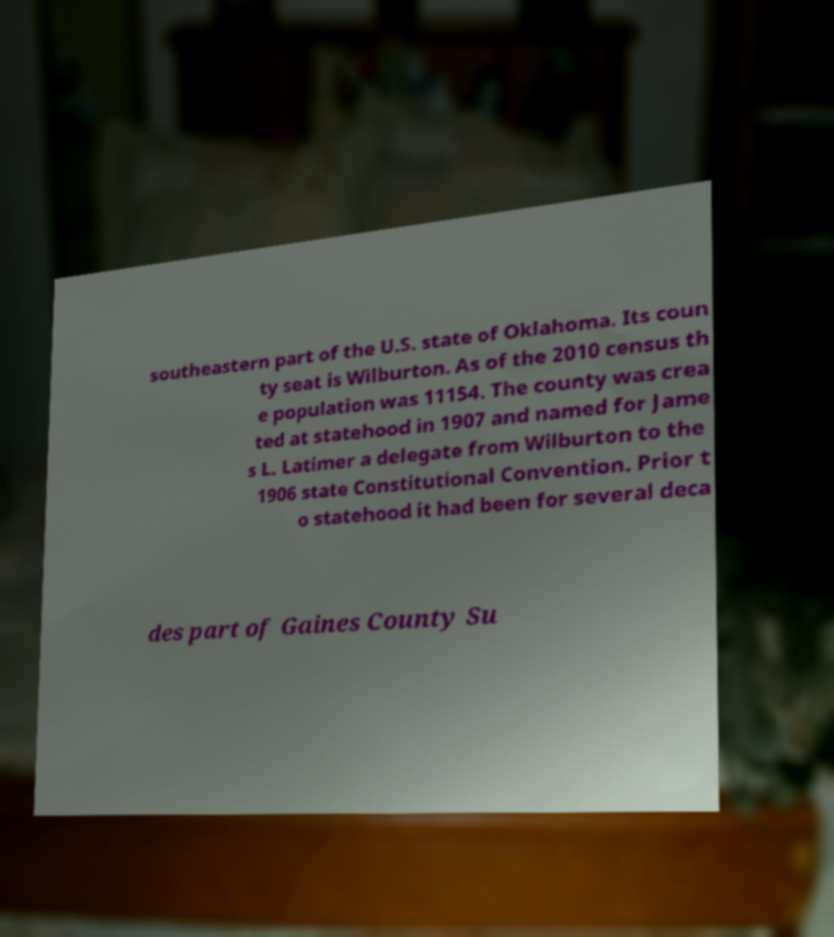For documentation purposes, I need the text within this image transcribed. Could you provide that? southeastern part of the U.S. state of Oklahoma. Its coun ty seat is Wilburton. As of the 2010 census th e population was 11154. The county was crea ted at statehood in 1907 and named for Jame s L. Latimer a delegate from Wilburton to the 1906 state Constitutional Convention. Prior t o statehood it had been for several deca des part of Gaines County Su 